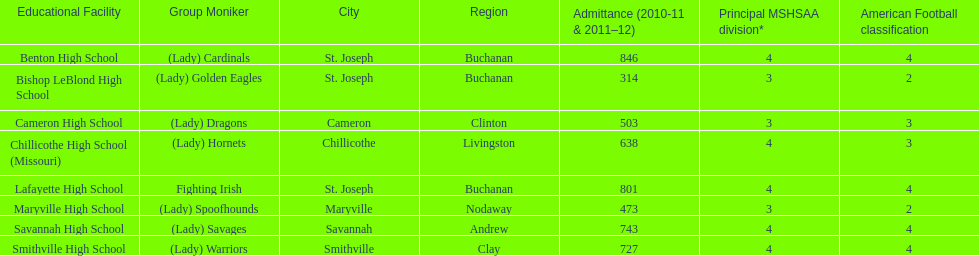What are the three schools in the town of st. joseph? St. Joseph, St. Joseph, St. Joseph. Of the three schools in st. joseph which school's team name does not depict a type of animal? Lafayette High School. 